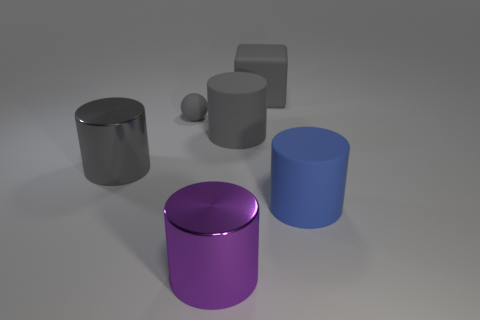Is there anything else that is the same size as the gray ball?
Keep it short and to the point. No. Is the material of the sphere the same as the large gray thing that is left of the large purple shiny object?
Keep it short and to the point. No. What number of large purple metal things are there?
Provide a short and direct response. 1. How big is the gray cylinder on the left side of the purple metallic cylinder?
Your answer should be compact. Large. How many purple shiny cylinders are the same size as the gray cube?
Provide a short and direct response. 1. The big cylinder that is both to the right of the large purple shiny cylinder and to the left of the blue cylinder is made of what material?
Your response must be concise. Rubber. What material is the other gray cylinder that is the same size as the gray rubber cylinder?
Your answer should be very brief. Metal. What is the size of the metallic thing in front of the matte cylinder in front of the gray cylinder left of the gray ball?
Offer a terse response. Large. The blue thing that is the same material as the big block is what size?
Keep it short and to the point. Large. Do the matte ball and the rubber cylinder behind the large blue matte thing have the same size?
Offer a terse response. No. 